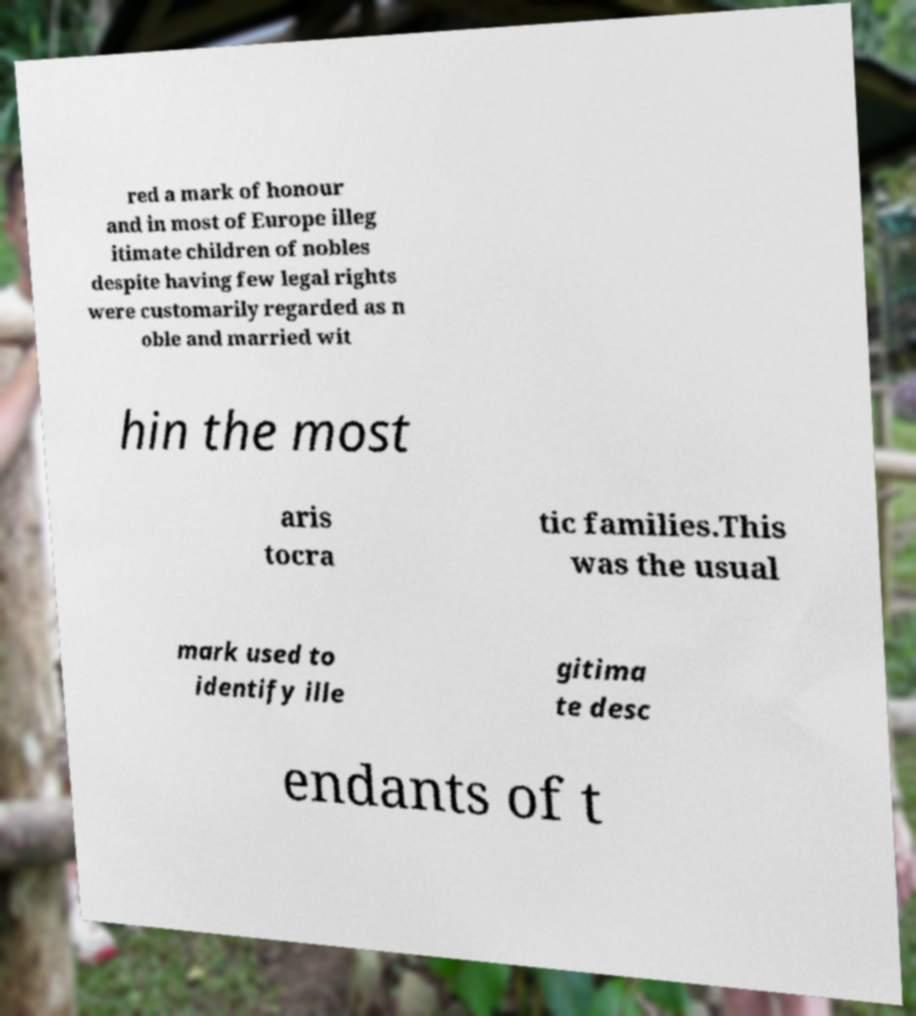For documentation purposes, I need the text within this image transcribed. Could you provide that? red a mark of honour and in most of Europe illeg itimate children of nobles despite having few legal rights were customarily regarded as n oble and married wit hin the most aris tocra tic families.This was the usual mark used to identify ille gitima te desc endants of t 